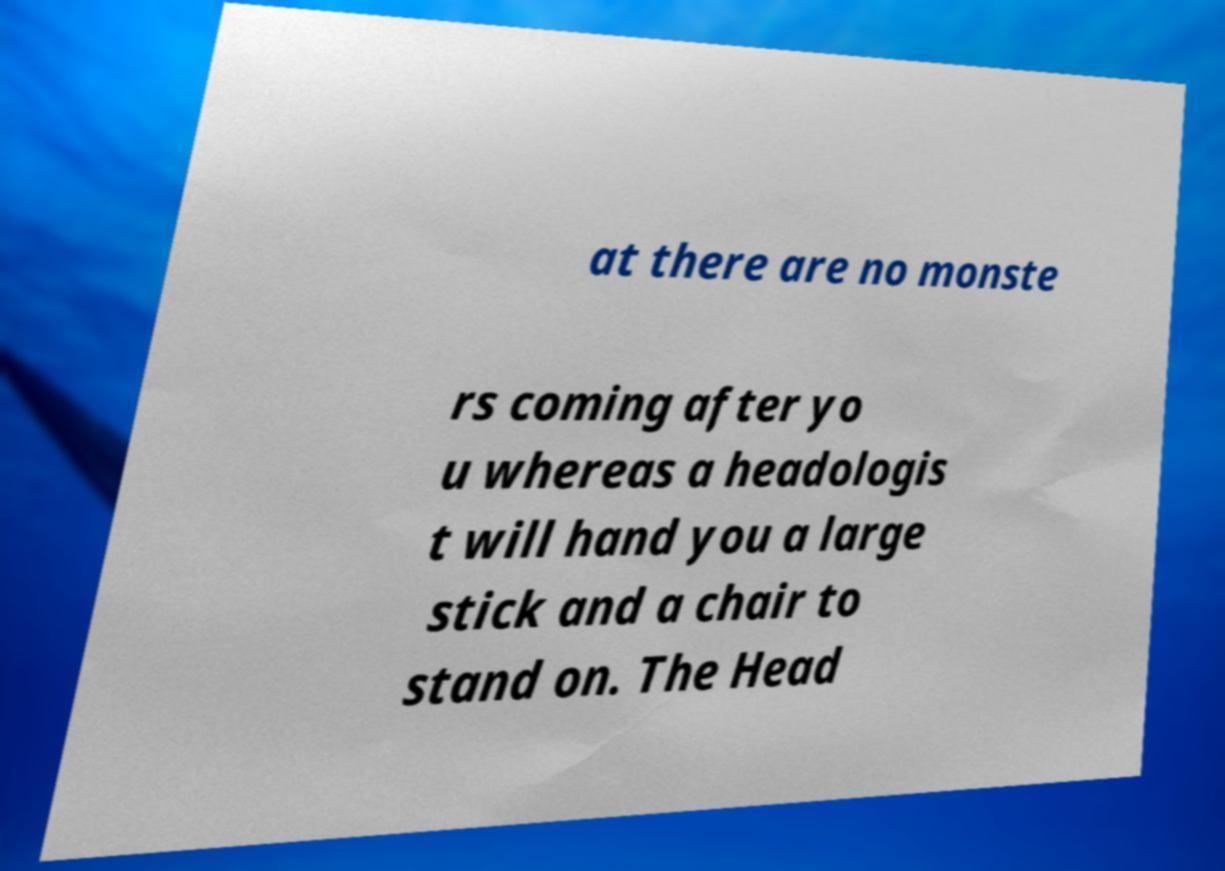Could you extract and type out the text from this image? at there are no monste rs coming after yo u whereas a headologis t will hand you a large stick and a chair to stand on. The Head 